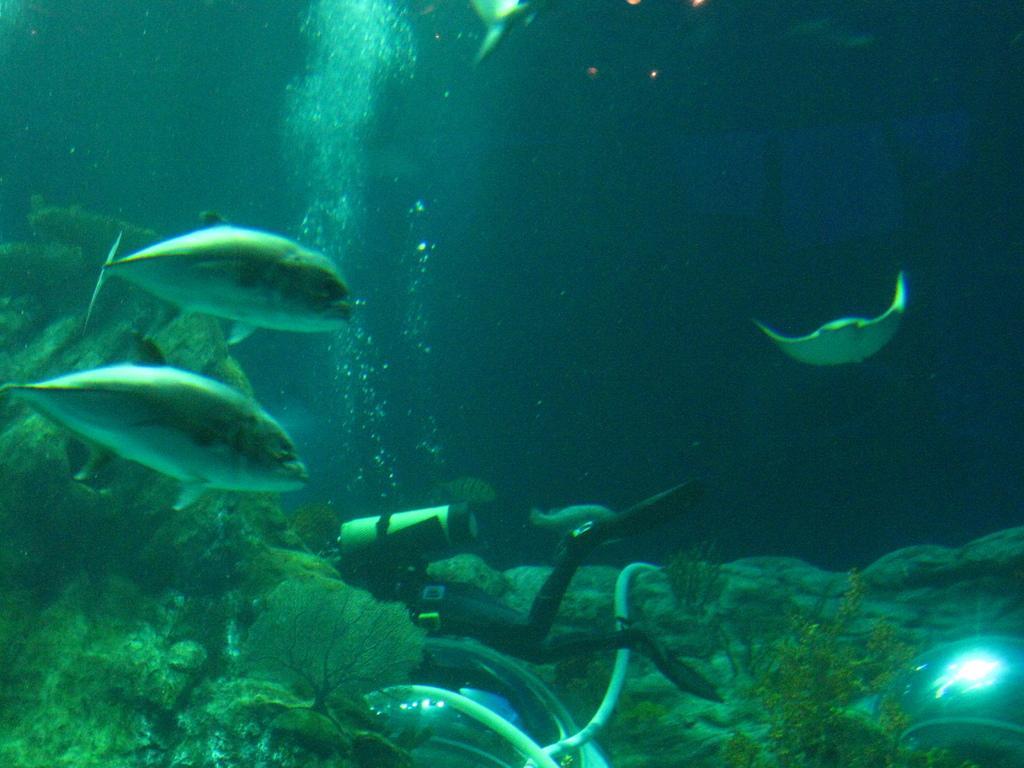Could you give a brief overview of what you see in this image? In this image I can see water and in it I can see few fishes and a person. I can also see a gas cylinder over here and I can see this image is little bit in dark. 